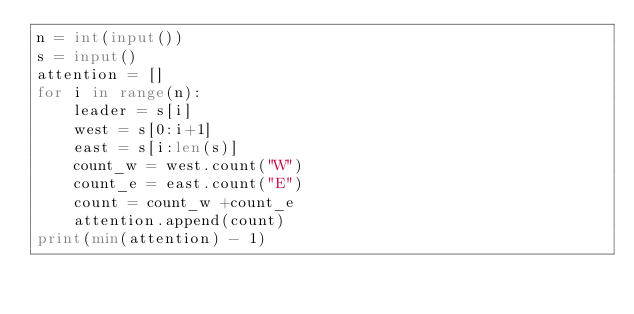Convert code to text. <code><loc_0><loc_0><loc_500><loc_500><_Python_>n = int(input())
s = input()
attention = []
for i in range(n):
    leader = s[i]
    west = s[0:i+1]
    east = s[i:len(s)]
    count_w = west.count("W")
    count_e = east.count("E")
    count = count_w +count_e
    attention.append(count)
print(min(attention) - 1)</code> 